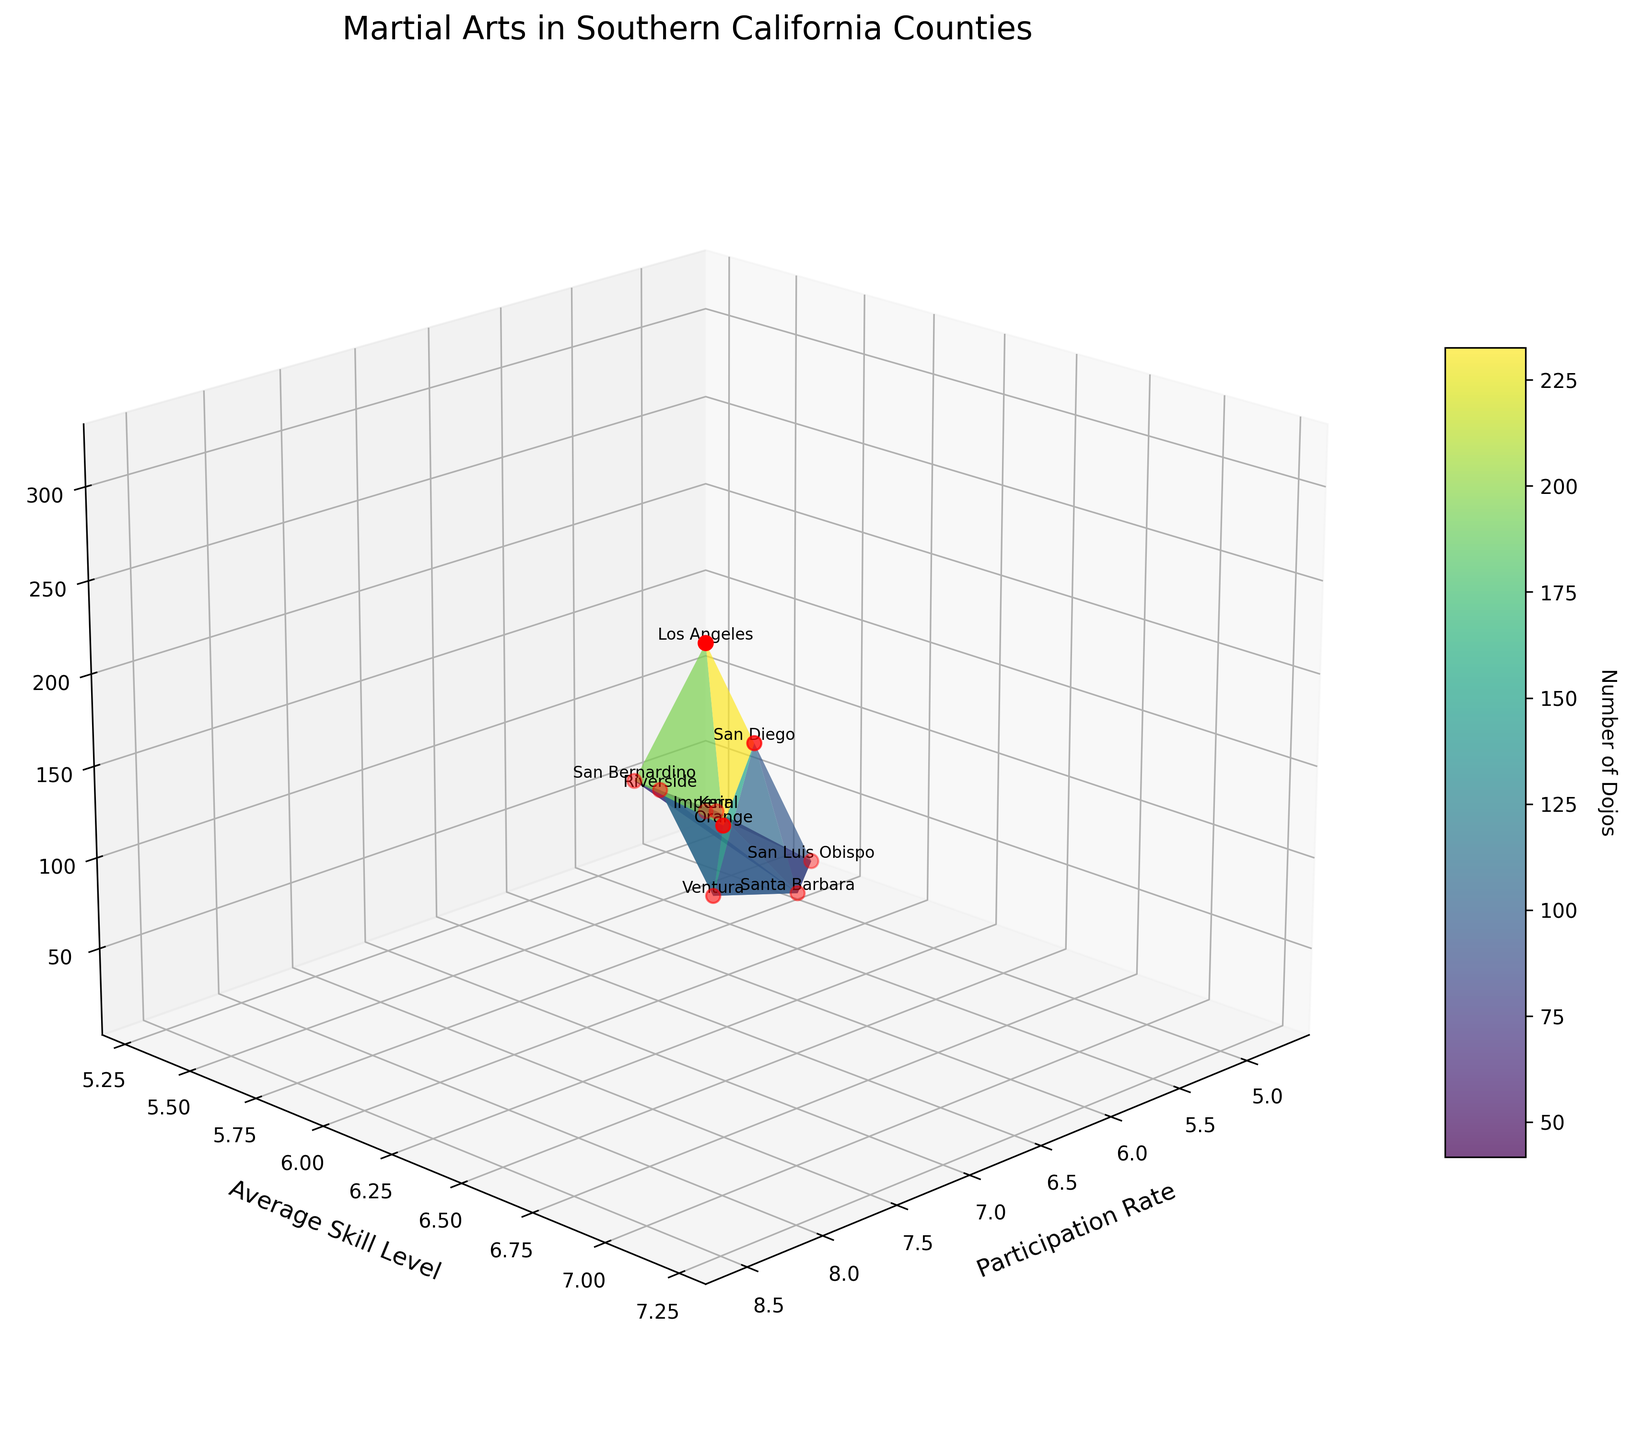What is the title of the figure? The title of the figure is usually located at the top and directly provides a summary of the data being presented.
Answer: Martial Arts in Southern California Counties How many counties are represented in the plot? By counting the number of data points or labels provided in the plot, each representing a county, we can determine the number of counties.
Answer: 10 Which county has the highest participation rate? By examining the "Participation Rate" axis and finding the highest value, we can identify the corresponding county.
Answer: Los Angeles Which county has the lowest average skill level? By checking the "Average Skill Level" axis and finding the lowest value, we can determine which county it is linked to.
Answer: Imperial How many dojos are there in Ventura county? By identifying the data point labeled "Ventura" and referring to the "Number of Dojos" axis, we can find the exact number.
Answer: 72 Compare the participation rates and average skill levels of Los Angeles and San Diego counties. By locating the data points for Los Angeles and San Diego on the plot and comparing their positions on the "Participation Rate" and "Average Skill Level" axes, we can assess the differences.
Answer: Los Angeles has higher rates and skill levels What is the second highest number of dojos, and which county has it? By examining the "Number of Dojos" axis and finding the second highest value, we can identify the corresponding county.
Answer: Orange, 185 Calculate the average participation rate of counties with more than 100 dojos. First, identify those counties and their participation rates: Los Angeles (8.5), Orange (7.8), San Diego (7.2). Then, calculate the average: (8.5 + 7.8 + 7.2) / 3 ≈ 7.83.
Answer: 7.83 What trend do you observe between participation rates and average skill levels? By examining the plot's general shape and distribution, we can determine if higher participation rates correlate with higher average skill levels.
Answer: Higher participation rates tend to correlate with higher skill levels Which county has a similar number of dojos as Riverside but a higher average skill level? Identify Riverside's number of dojos (98), then find a county with a close number and higher average skill level. San Luis Obispo has 38 dojos (closest) and a skill level of 5.9 vs Riverside’s 5.8.
Answer: San Luis Obispo 